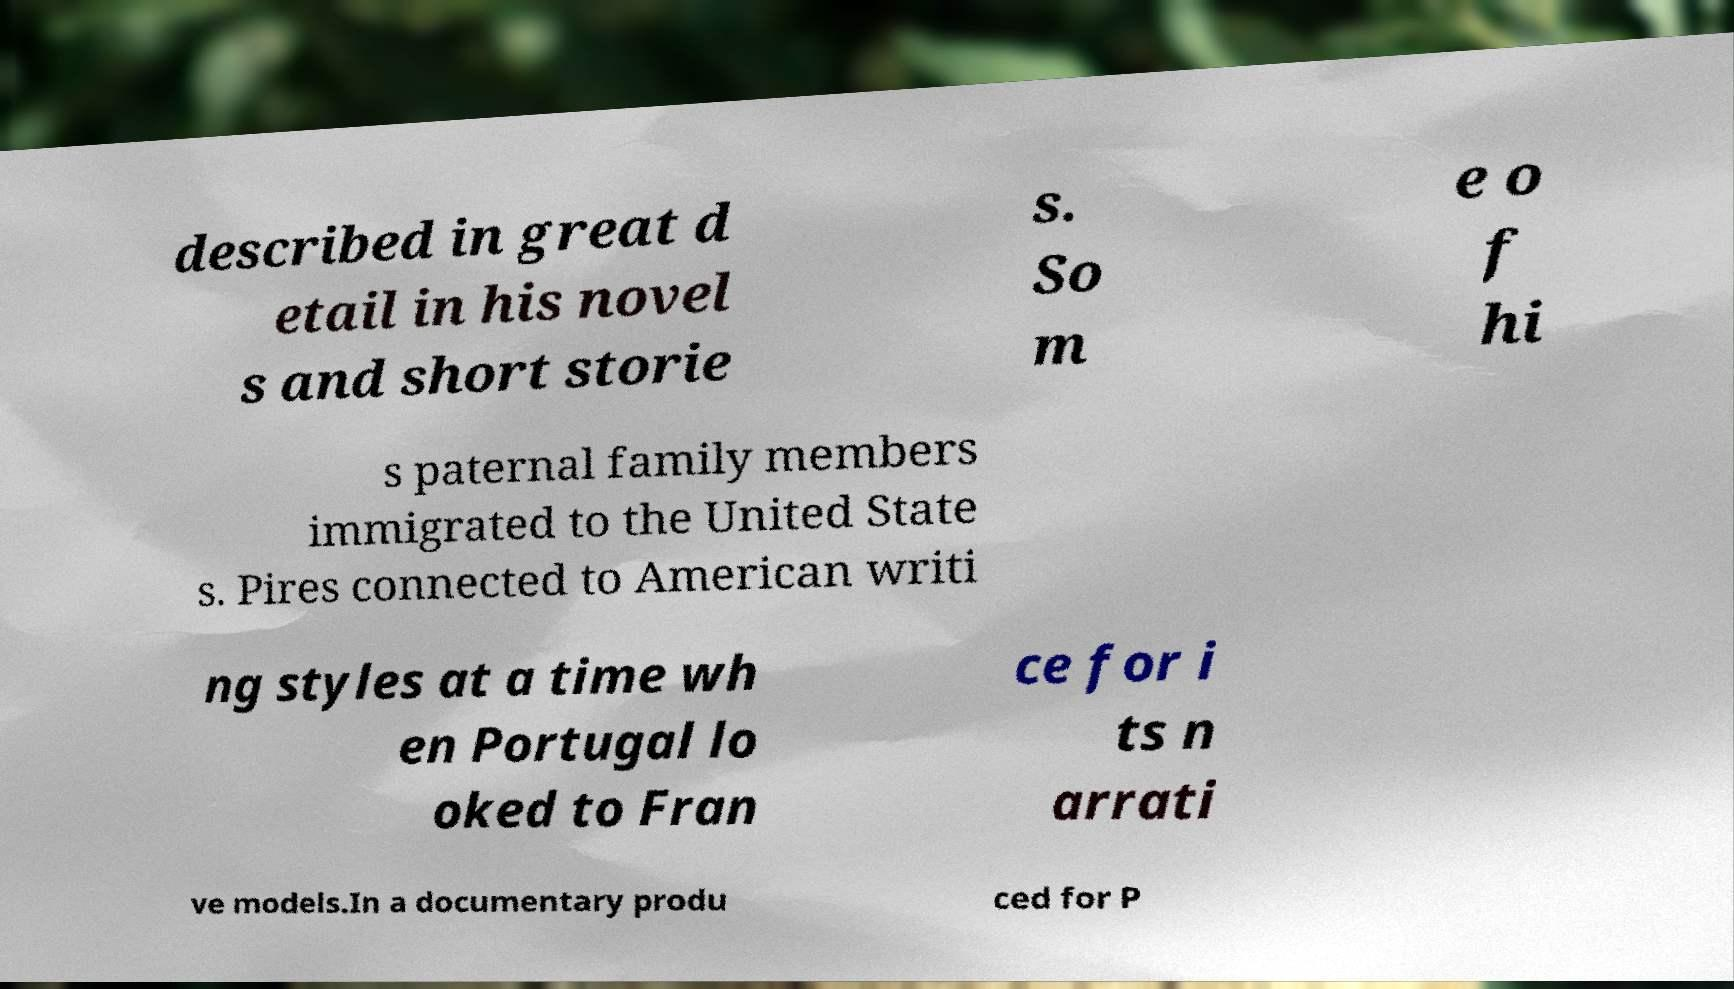There's text embedded in this image that I need extracted. Can you transcribe it verbatim? described in great d etail in his novel s and short storie s. So m e o f hi s paternal family members immigrated to the United State s. Pires connected to American writi ng styles at a time wh en Portugal lo oked to Fran ce for i ts n arrati ve models.In a documentary produ ced for P 